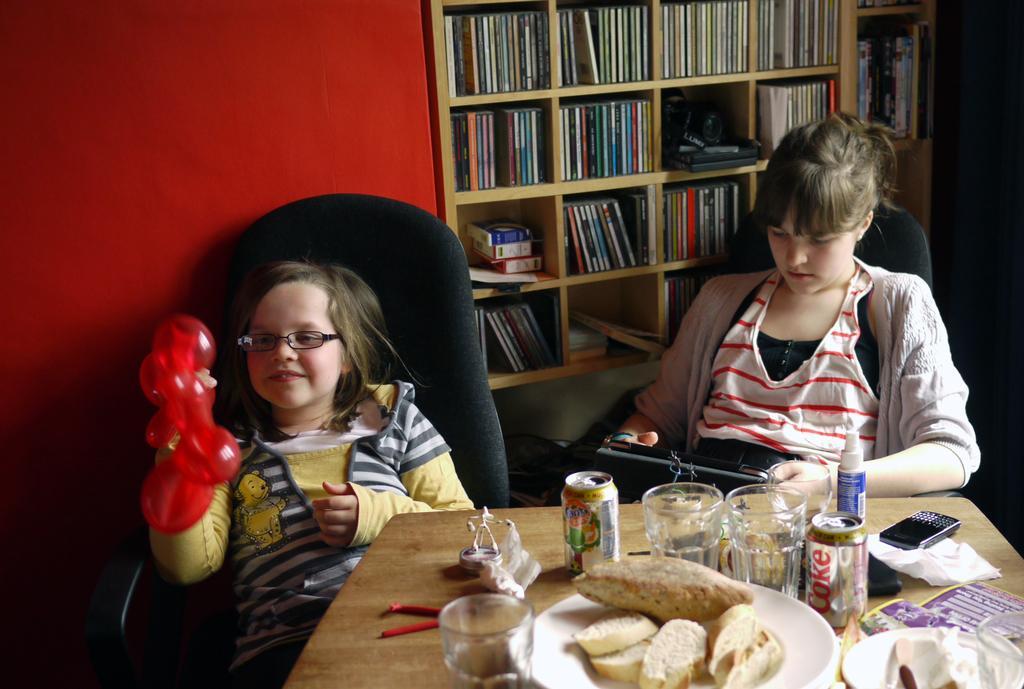Could you give a brief overview of what you see in this image? In this picture there is a girl sitting on a chair and holding an object. There is a woman sitting on the chair. There are many books in the shelf. There is a glass , tin, food in the plate, phone and other items in the table. 